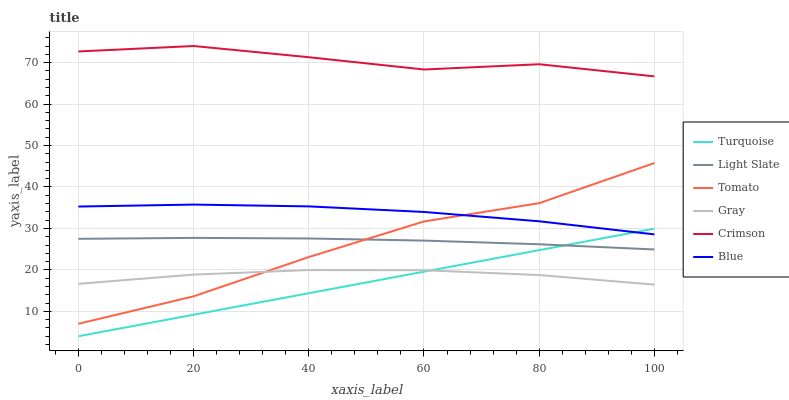Does Turquoise have the minimum area under the curve?
Answer yes or no. Yes. Does Crimson have the maximum area under the curve?
Answer yes or no. Yes. Does Blue have the minimum area under the curve?
Answer yes or no. No. Does Blue have the maximum area under the curve?
Answer yes or no. No. Is Turquoise the smoothest?
Answer yes or no. Yes. Is Tomato the roughest?
Answer yes or no. Yes. Is Blue the smoothest?
Answer yes or no. No. Is Blue the roughest?
Answer yes or no. No. Does Turquoise have the lowest value?
Answer yes or no. Yes. Does Blue have the lowest value?
Answer yes or no. No. Does Crimson have the highest value?
Answer yes or no. Yes. Does Blue have the highest value?
Answer yes or no. No. Is Gray less than Crimson?
Answer yes or no. Yes. Is Crimson greater than Light Slate?
Answer yes or no. Yes. Does Turquoise intersect Blue?
Answer yes or no. Yes. Is Turquoise less than Blue?
Answer yes or no. No. Is Turquoise greater than Blue?
Answer yes or no. No. Does Gray intersect Crimson?
Answer yes or no. No. 